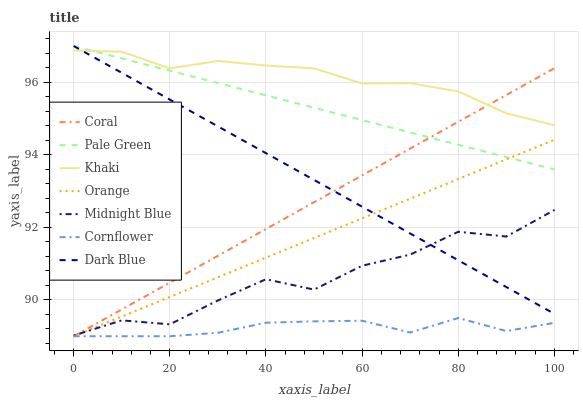Does Midnight Blue have the minimum area under the curve?
Answer yes or no. No. Does Midnight Blue have the maximum area under the curve?
Answer yes or no. No. Is Khaki the smoothest?
Answer yes or no. No. Is Khaki the roughest?
Answer yes or no. No. Does Midnight Blue have the lowest value?
Answer yes or no. No. Does Khaki have the highest value?
Answer yes or no. No. Is Cornflower less than Dark Blue?
Answer yes or no. Yes. Is Midnight Blue greater than Cornflower?
Answer yes or no. Yes. Does Cornflower intersect Dark Blue?
Answer yes or no. No. 